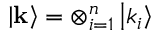<formula> <loc_0><loc_0><loc_500><loc_500>\left | k \right \rangle = \otimes _ { i = 1 } ^ { n } \left | k _ { i } \right \rangle</formula> 